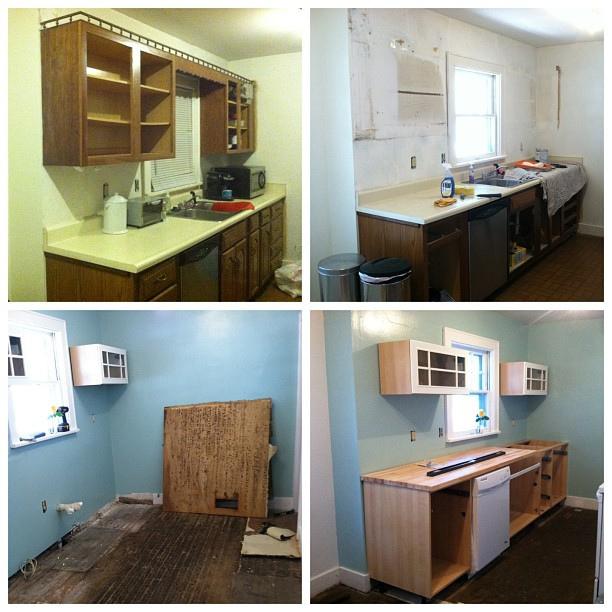How many pictures are shown here?
Concise answer only. 4. What room is this?
Answer briefly. Kitchen. Is the same room featured on all four pictures?
Write a very short answer. Yes. 